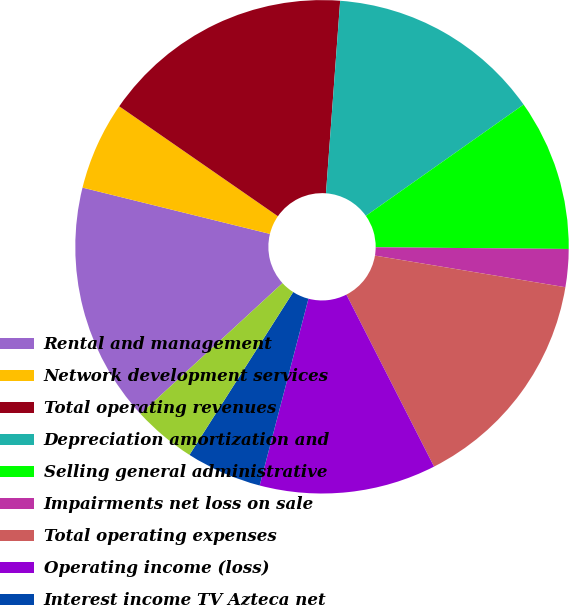Convert chart to OTSL. <chart><loc_0><loc_0><loc_500><loc_500><pie_chart><fcel>Rental and management<fcel>Network development services<fcel>Total operating revenues<fcel>Depreciation amortization and<fcel>Selling general administrative<fcel>Impairments net loss on sale<fcel>Total operating expenses<fcel>Operating income (loss)<fcel>Interest income TV Azteca net<fcel>Interest income<nl><fcel>15.7%<fcel>5.79%<fcel>16.53%<fcel>14.05%<fcel>9.92%<fcel>2.48%<fcel>14.88%<fcel>11.57%<fcel>4.96%<fcel>4.13%<nl></chart> 